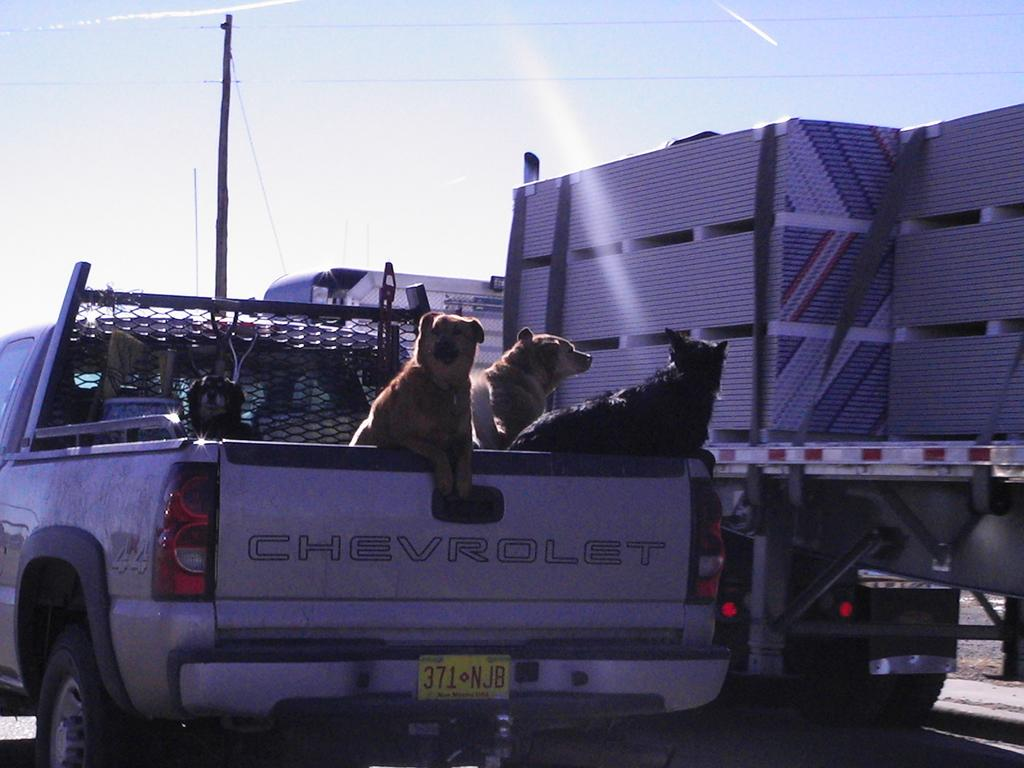What animals are present in the vehicle in the image? There are dogs in the car. What type of vehicle is visible on the right hand side of the image? There is a vehicle on the right hand side of the image. What is located at the top left hand corner of the image? There is an electric pole at the top left hand corner of the image. What can be seen in the sky in the image? The sky is clear and visible in the image. Can you tell me if the lake in the image has received approval for swimming? There is no lake present in the image, so it is not possible to determine if it has received approval for swimming. What type of idea is being discussed by the dogs in the car? There is no indication in the image that the dogs are discussing any ideas. 